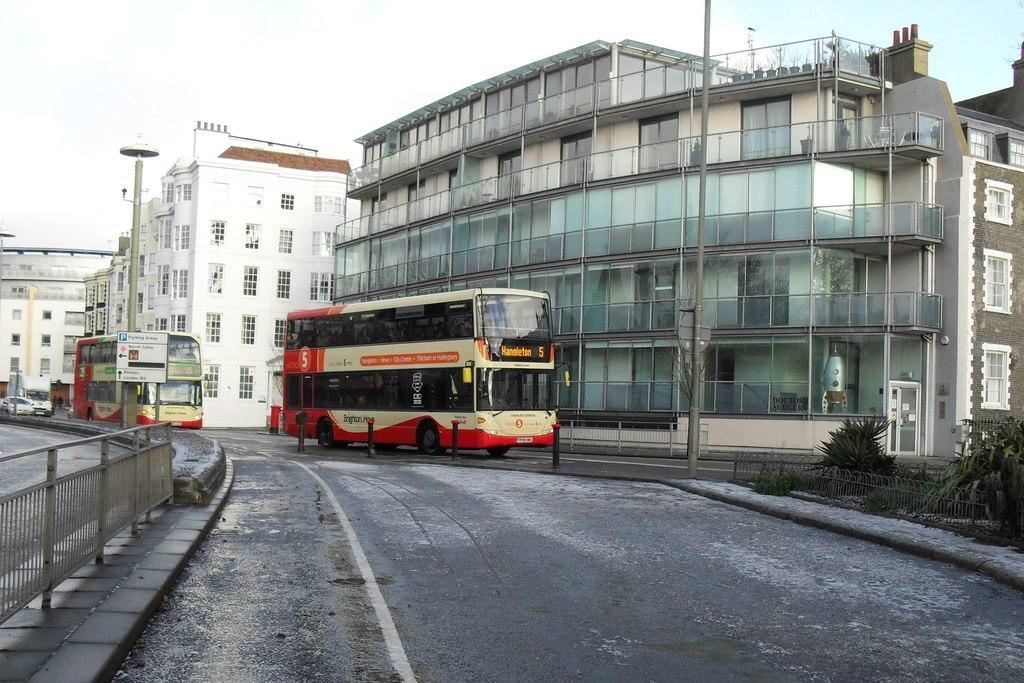What type of buses can be seen in the image? There are Double Decker buses in the image. What else is present on the road in the image? There are vehicles on the road in the image. What type of vegetation is visible in the image? There are plants in the image. What architectural features can be seen in the image? There are iron grilles and poles in the image. What type of structures are present in the image? There are buildings in the image. What is visible in the background of the image? The sky is visible in the background of the image. Where is the bedroom located in the image? There is no bedroom present in the image. What type of destruction can be seen in the image? There is no destruction present in the image. Can you see any boats in the image? There are no boats present in the image. 